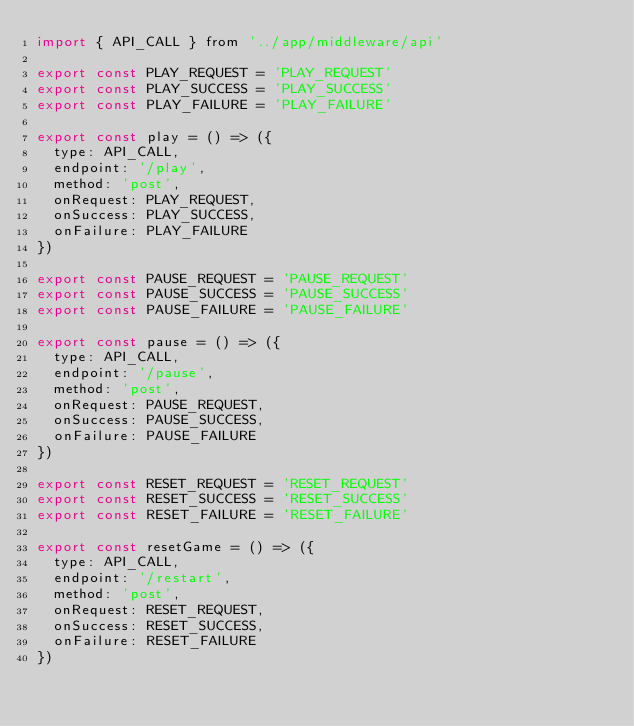<code> <loc_0><loc_0><loc_500><loc_500><_JavaScript_>import { API_CALL } from '../app/middleware/api'

export const PLAY_REQUEST = 'PLAY_REQUEST'
export const PLAY_SUCCESS = 'PLAY_SUCCESS'
export const PLAY_FAILURE = 'PLAY_FAILURE'

export const play = () => ({
  type: API_CALL,
  endpoint: '/play',
  method: 'post',
  onRequest: PLAY_REQUEST,
  onSuccess: PLAY_SUCCESS,
  onFailure: PLAY_FAILURE
})

export const PAUSE_REQUEST = 'PAUSE_REQUEST'
export const PAUSE_SUCCESS = 'PAUSE_SUCCESS'
export const PAUSE_FAILURE = 'PAUSE_FAILURE'

export const pause = () => ({
  type: API_CALL,
  endpoint: '/pause',
  method: 'post',
  onRequest: PAUSE_REQUEST,
  onSuccess: PAUSE_SUCCESS,
  onFailure: PAUSE_FAILURE
})

export const RESET_REQUEST = 'RESET_REQUEST'
export const RESET_SUCCESS = 'RESET_SUCCESS'
export const RESET_FAILURE = 'RESET_FAILURE'

export const resetGame = () => ({
  type: API_CALL,
  endpoint: '/restart',
  method: 'post',
  onRequest: RESET_REQUEST,
  onSuccess: RESET_SUCCESS,
  onFailure: RESET_FAILURE
})

</code> 